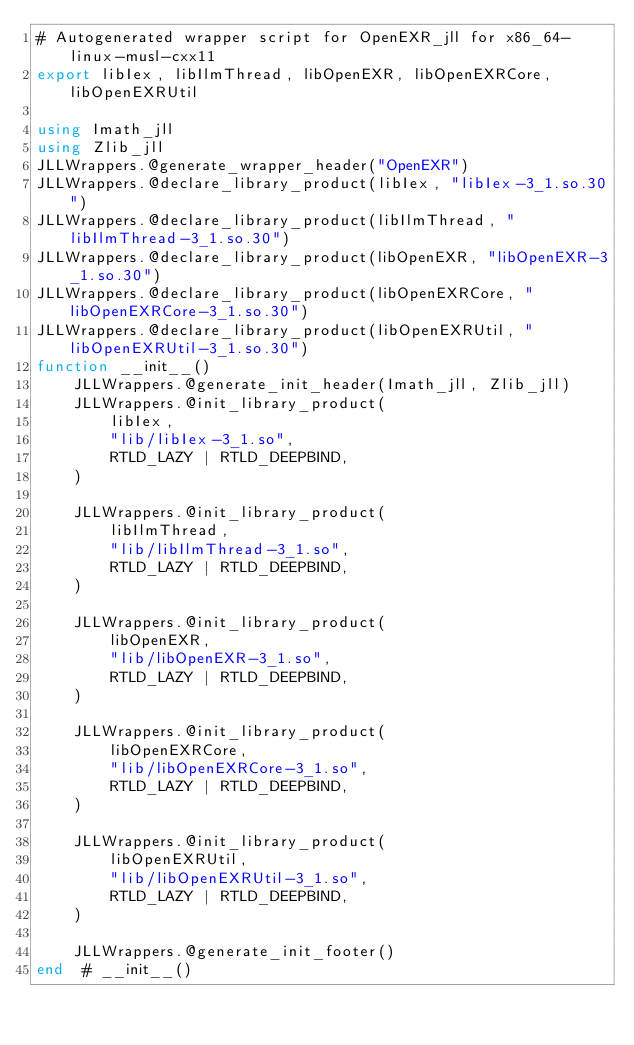<code> <loc_0><loc_0><loc_500><loc_500><_Julia_># Autogenerated wrapper script for OpenEXR_jll for x86_64-linux-musl-cxx11
export libIex, libIlmThread, libOpenEXR, libOpenEXRCore, libOpenEXRUtil

using Imath_jll
using Zlib_jll
JLLWrappers.@generate_wrapper_header("OpenEXR")
JLLWrappers.@declare_library_product(libIex, "libIex-3_1.so.30")
JLLWrappers.@declare_library_product(libIlmThread, "libIlmThread-3_1.so.30")
JLLWrappers.@declare_library_product(libOpenEXR, "libOpenEXR-3_1.so.30")
JLLWrappers.@declare_library_product(libOpenEXRCore, "libOpenEXRCore-3_1.so.30")
JLLWrappers.@declare_library_product(libOpenEXRUtil, "libOpenEXRUtil-3_1.so.30")
function __init__()
    JLLWrappers.@generate_init_header(Imath_jll, Zlib_jll)
    JLLWrappers.@init_library_product(
        libIex,
        "lib/libIex-3_1.so",
        RTLD_LAZY | RTLD_DEEPBIND,
    )

    JLLWrappers.@init_library_product(
        libIlmThread,
        "lib/libIlmThread-3_1.so",
        RTLD_LAZY | RTLD_DEEPBIND,
    )

    JLLWrappers.@init_library_product(
        libOpenEXR,
        "lib/libOpenEXR-3_1.so",
        RTLD_LAZY | RTLD_DEEPBIND,
    )

    JLLWrappers.@init_library_product(
        libOpenEXRCore,
        "lib/libOpenEXRCore-3_1.so",
        RTLD_LAZY | RTLD_DEEPBIND,
    )

    JLLWrappers.@init_library_product(
        libOpenEXRUtil,
        "lib/libOpenEXRUtil-3_1.so",
        RTLD_LAZY | RTLD_DEEPBIND,
    )

    JLLWrappers.@generate_init_footer()
end  # __init__()
</code> 